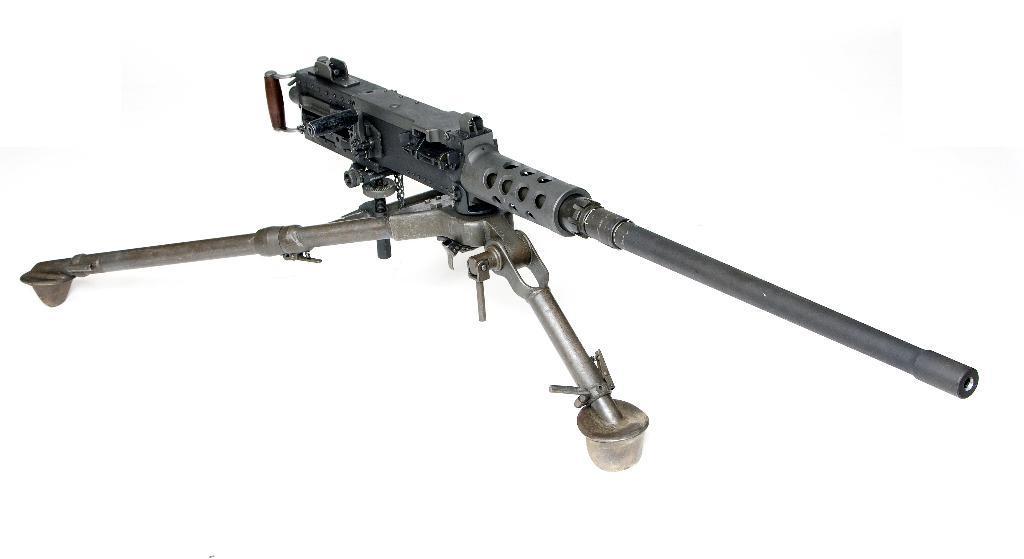Can you describe this image briefly? In this image there is a gun. Background is in white color. 